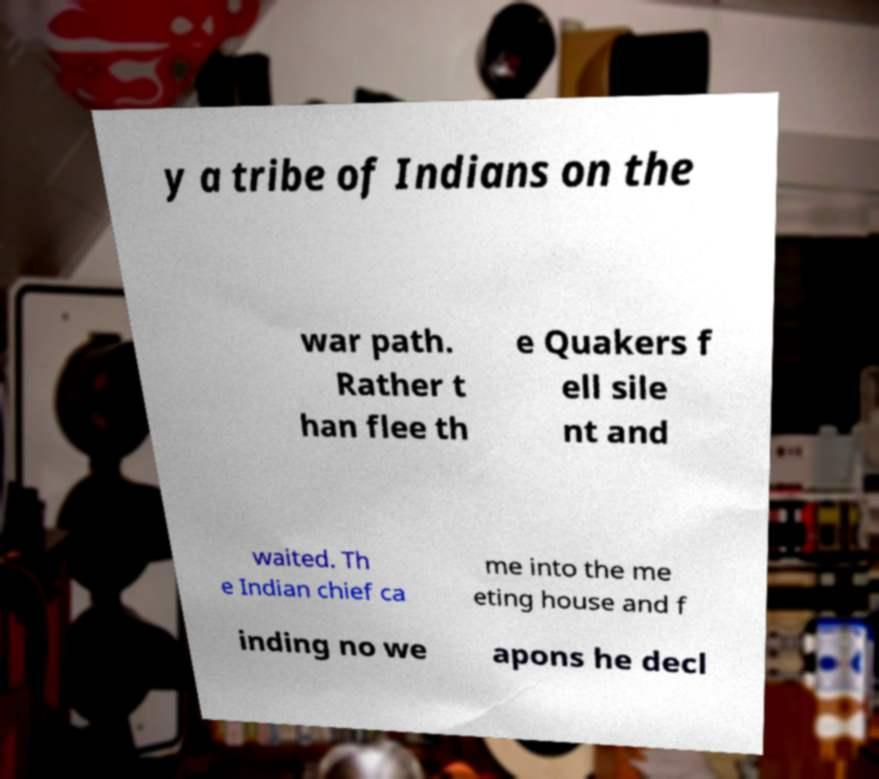Could you extract and type out the text from this image? y a tribe of Indians on the war path. Rather t han flee th e Quakers f ell sile nt and waited. Th e Indian chief ca me into the me eting house and f inding no we apons he decl 